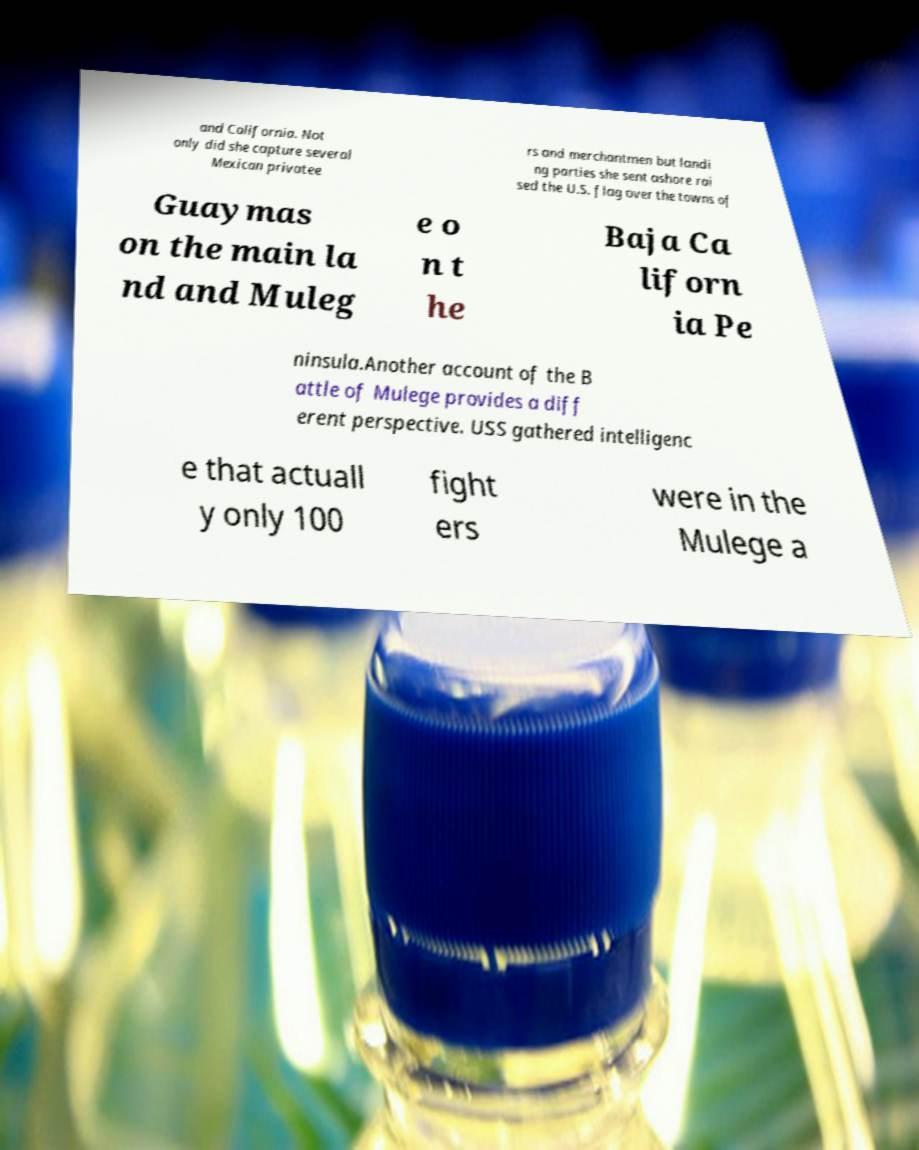Can you accurately transcribe the text from the provided image for me? and California. Not only did she capture several Mexican privatee rs and merchantmen but landi ng parties she sent ashore rai sed the U.S. flag over the towns of Guaymas on the main la nd and Muleg e o n t he Baja Ca liforn ia Pe ninsula.Another account of the B attle of Mulege provides a diff erent perspective. USS gathered intelligenc e that actuall y only 100 fight ers were in the Mulege a 